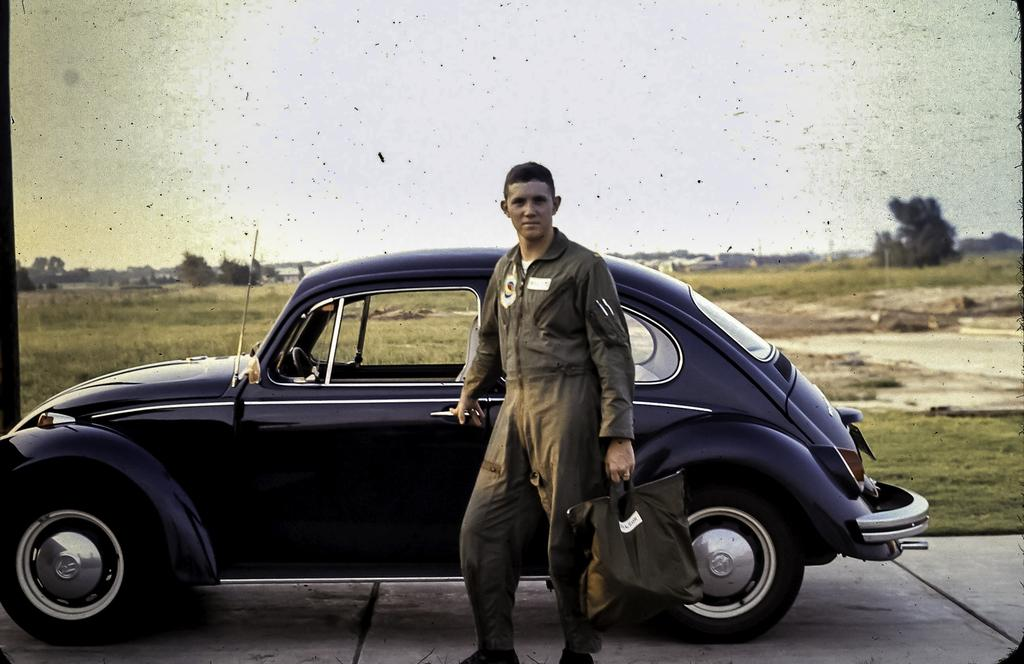What is the main subject of the image? There is a man standing in the image. What can be observed about the man's attire? The man is wearing clothes. What is the man carrying in the image? The man is carrying a bag. What type of transportation is present in the image? There is a vehicle in the image. What is the setting of the image? The image features a road, grass, trees, and the sky. What type of polish is being applied to the vehicle in the image? There is no mention of polish or any vehicle maintenance in the provided facts. --- Facts: 1. There is a person in the image. 2. The person is holding a book. 3. The book is titled "The Art of War" by Sun Tzu. 4. The person is sitting on a chair. 5. The chair is made of wood. 6. The person is wearing glasses. 7. The person is reading the book. Absurd Topics: elephant, piano, chessboard Conversation: What is the main subject in the image? There is a person in the image. What is the person holding in the image? The person is holding a book. What is the title of the book the person is holding? The book is titled "The Art of War" by Sun Tzu. What is the person's position in the image? The person is sitting on a chair. What is the chair made of? The chair is made of wood. What is the person wearing in the image? The person is wearing glasses. What is the person doing with the book in the image? The person is reading the book. Reasoning: Let's think step by step in order to produce the conversation. We start by identifying the main subject of the image, which is the person. Then, we describe what the person is holding, which is a book. Next, we mention the title of the book, which is "The Art of War" by Sun Tzu. After that, we observe the person's position, which is sitting on a chair. Then, we describe the material of the chair, which is made of wood. Following that, we acknowledge what the person is wearing, which are glasses. Finally, we describe what the person is doing with the book, which is reading the book. Absurd Question/Answer: Can you hear the elephant playing the piano in the image? There is no mention of an elephant, a piano, or any musical instruments in the provided facts. 